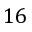Convert formula to latex. <formula><loc_0><loc_0><loc_500><loc_500>1 6</formula> 